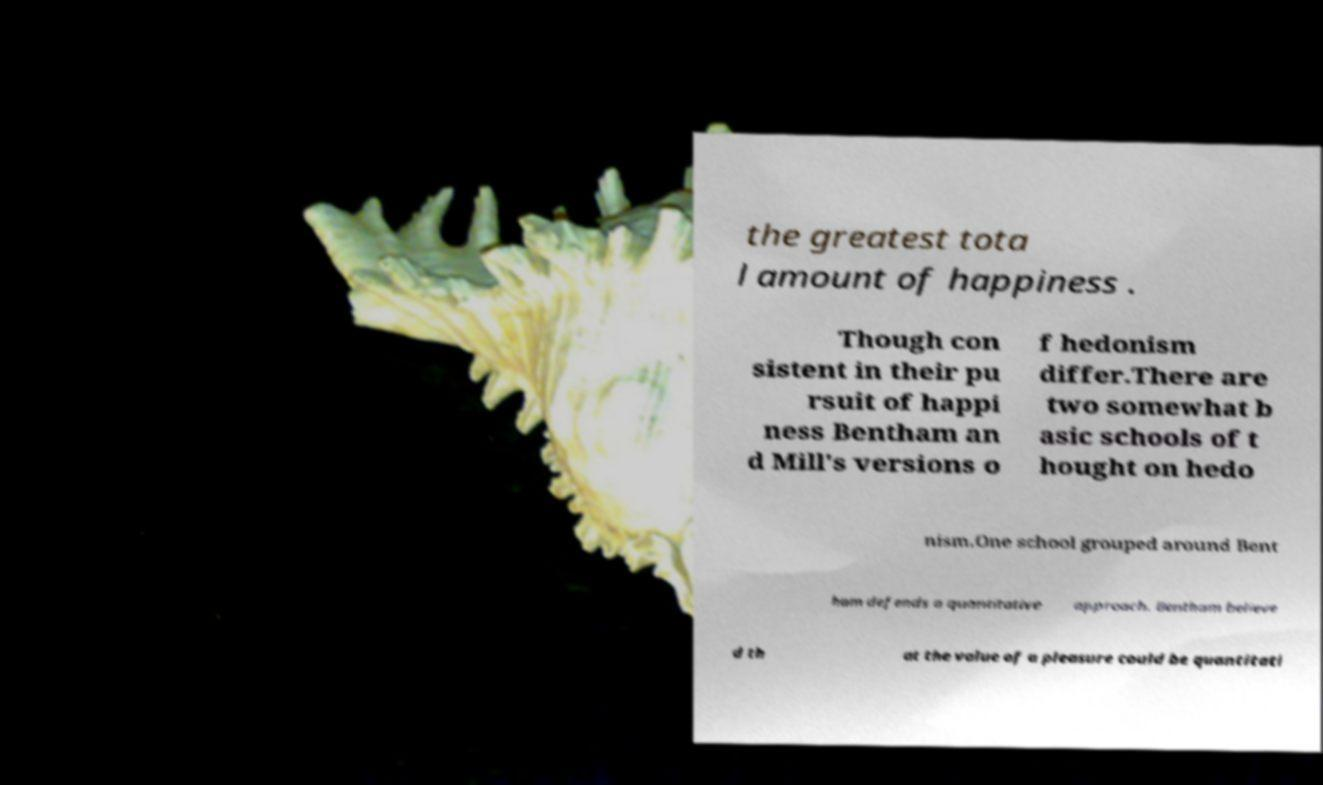I need the written content from this picture converted into text. Can you do that? the greatest tota l amount of happiness . Though con sistent in their pu rsuit of happi ness Bentham an d Mill's versions o f hedonism differ.There are two somewhat b asic schools of t hought on hedo nism.One school grouped around Bent ham defends a quantitative approach. Bentham believe d th at the value of a pleasure could be quantitati 